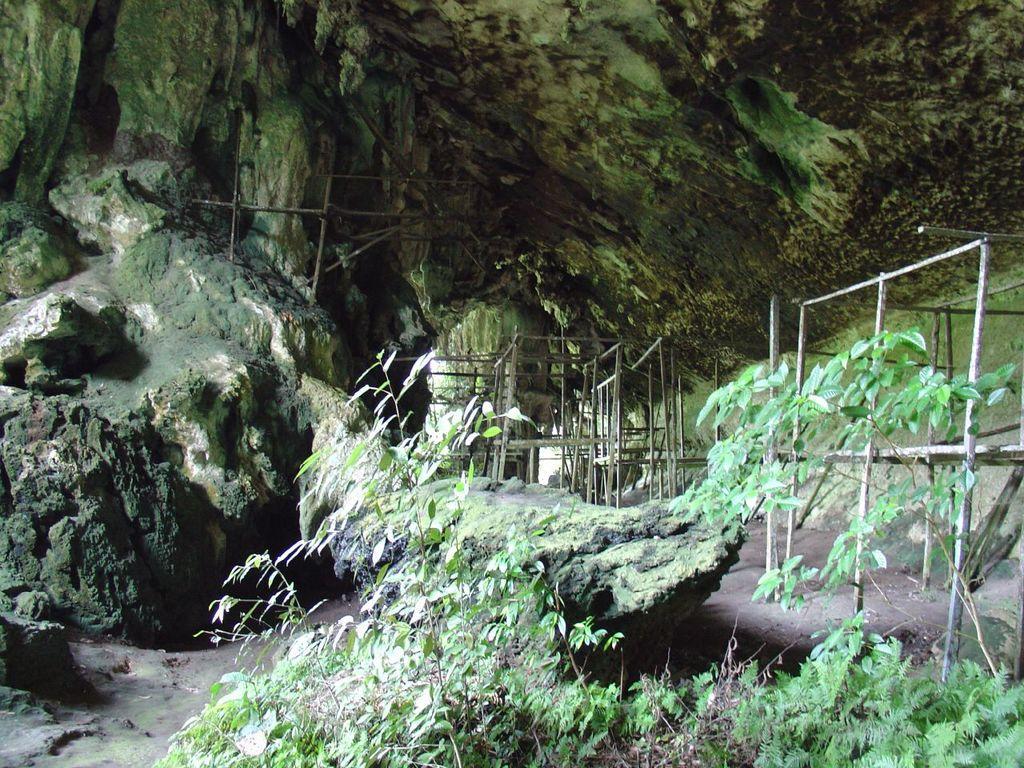Could you give a brief overview of what you see in this image? In this image in the foreground there are plants. In the background there are hills. This is looking like a tunnel. These are fences. 